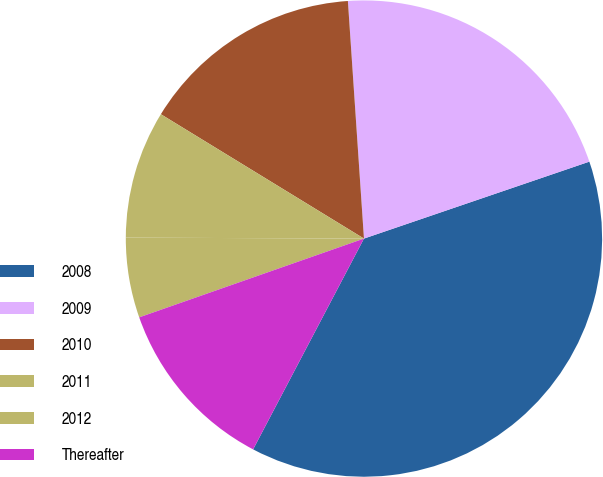<chart> <loc_0><loc_0><loc_500><loc_500><pie_chart><fcel>2008<fcel>2009<fcel>2010<fcel>2011<fcel>2012<fcel>Thereafter<nl><fcel>37.94%<fcel>20.84%<fcel>15.18%<fcel>8.68%<fcel>5.43%<fcel>11.93%<nl></chart> 